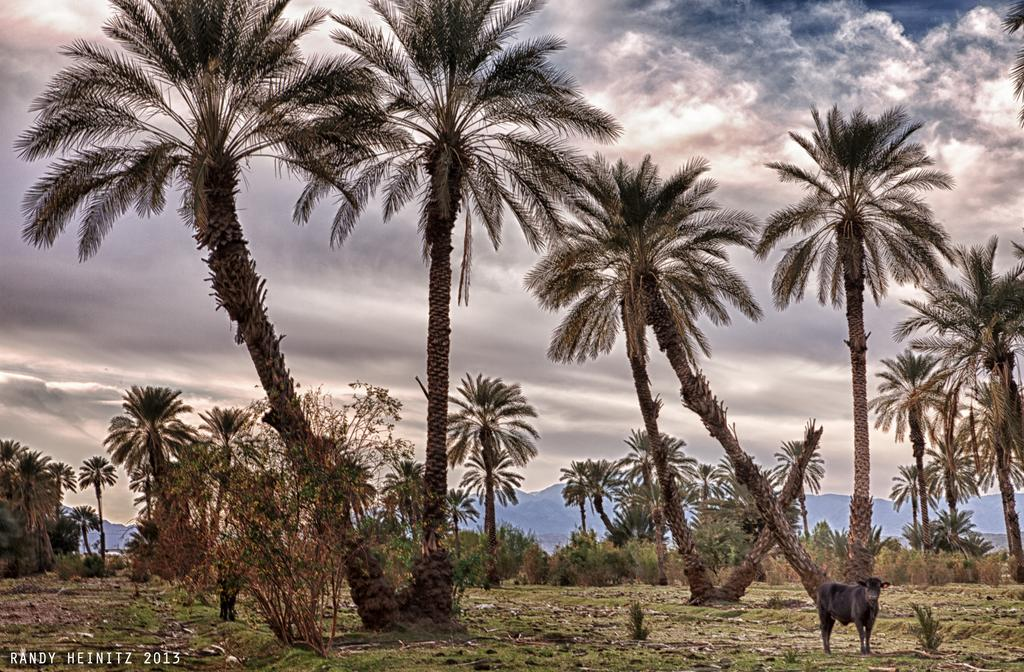What type of living creature is in the image? There is an animal in the image. What other natural elements can be seen in the image? There are plants and trees in the image. What part of the natural environment is visible in the image? The sky is visible in the image. Is there any text present in the image? Yes, there is text on the image. How much sand can be seen in the image? There is no sand present in the image. What type of trade is being conducted in the image? There is no trade being conducted in the image. 